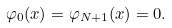Convert formula to latex. <formula><loc_0><loc_0><loc_500><loc_500>\varphi _ { 0 } ( x ) = \varphi _ { N + 1 } ( x ) = 0 .</formula> 